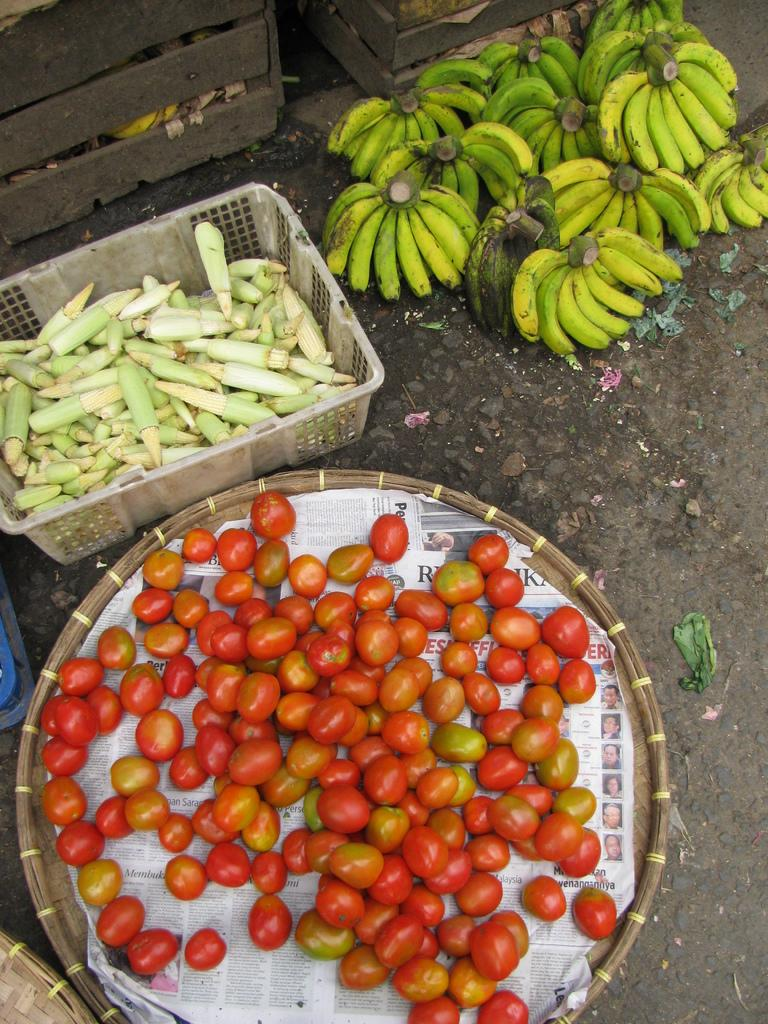What type of fruits are in the basket in the image? There are tomatoes in a basket in the image. What type of vegetable is in the container in the image? There are corn in a container in the image. What type of storage containers are present in the image? There are wooden boxes in the image. What type of fruit is placed on the ground in the image? There is a bunch of bananas placed on the ground in the image. How many goldfish are swimming in the jar in the image? There are no goldfish or jars present in the image. What type of card is visible in the image? There is no card visible in the image. 